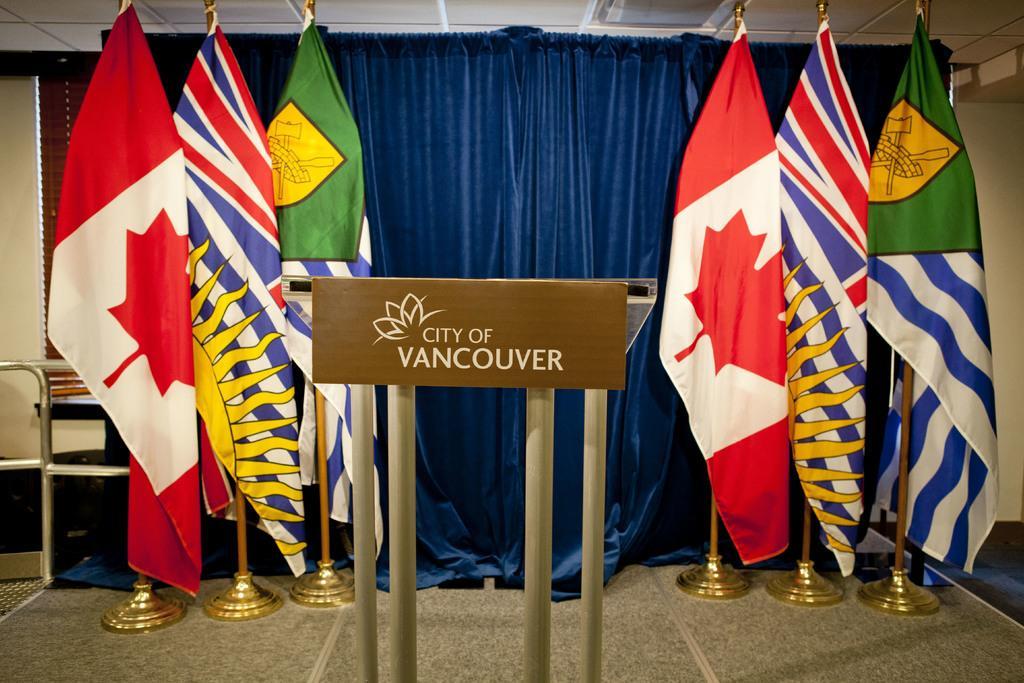Can you describe this image briefly? In this image there is a board with rods and some text on it, behind them there are a few flags and curtains, behind that there is a blind window and a wall. At the top of the image there is a ceiling. 